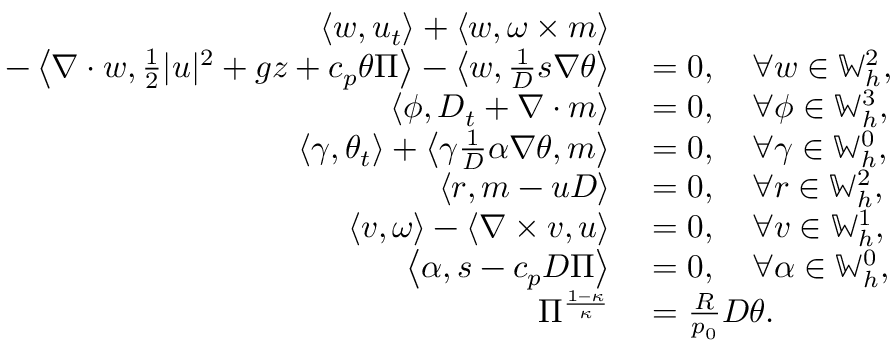Convert formula to latex. <formula><loc_0><loc_0><loc_500><loc_500>\begin{array} { r l } { \left \langle w , u _ { t } \right \rangle + \left \langle w , \omega \times m \right \rangle } \\ { \quad - \left \langle \nabla \cdot w , \frac { 1 } { 2 } | u | ^ { 2 } + g z + c _ { p } \theta \Pi \right \rangle - \left \langle w , \frac { 1 } { D } s \nabla \theta \right \rangle } & = 0 , \quad \forall w \in \mathbb { W } _ { h } ^ { 2 } , } \\ { \left \langle \phi , D _ { t } + \nabla \cdot m \right \rangle } & = 0 , \quad \forall \phi \in \mathbb { W } _ { h } ^ { 3 } , } \\ { \left \langle \gamma , \theta _ { t } \right \rangle + \left \langle \gamma \frac { 1 } { D } \alpha \nabla \theta , m \right \rangle } & = 0 , \quad \forall \gamma \in \mathbb { W } _ { h } ^ { 0 } , } \\ { \left \langle r , m - u D \right \rangle } & = 0 , \quad \forall r \in \mathbb { W } _ { h } ^ { 2 } , } \\ { \left \langle v , \omega \right \rangle - \left \langle \nabla \times v , u \right \rangle } & = 0 , \quad \forall v \in \mathbb { W } _ { h } ^ { 1 } , } \\ { \left \langle \alpha , s - c _ { p } D \Pi \right \rangle } & = 0 , \quad \forall \alpha \in \mathbb { W } _ { h } ^ { 0 } , } \\ { \Pi ^ { \frac { 1 - \kappa } { \kappa } } } & = \frac { R } { p _ { 0 } } D \theta . } \end{array}</formula> 